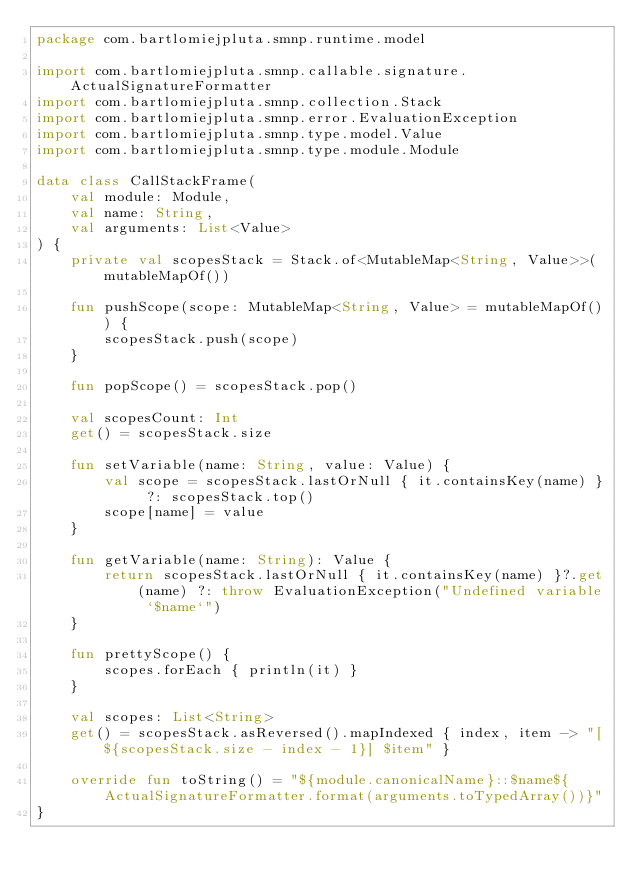<code> <loc_0><loc_0><loc_500><loc_500><_Kotlin_>package com.bartlomiejpluta.smnp.runtime.model

import com.bartlomiejpluta.smnp.callable.signature.ActualSignatureFormatter
import com.bartlomiejpluta.smnp.collection.Stack
import com.bartlomiejpluta.smnp.error.EvaluationException
import com.bartlomiejpluta.smnp.type.model.Value
import com.bartlomiejpluta.smnp.type.module.Module

data class CallStackFrame(
    val module: Module,
    val name: String,
    val arguments: List<Value>
) {
    private val scopesStack = Stack.of<MutableMap<String, Value>>(mutableMapOf())

    fun pushScope(scope: MutableMap<String, Value> = mutableMapOf()) {
        scopesStack.push(scope)
    }

    fun popScope() = scopesStack.pop()

    val scopesCount: Int
    get() = scopesStack.size

    fun setVariable(name: String, value: Value) {
        val scope = scopesStack.lastOrNull { it.containsKey(name) } ?: scopesStack.top()
        scope[name] = value
    }

    fun getVariable(name: String): Value {
        return scopesStack.lastOrNull { it.containsKey(name) }?.get(name) ?: throw EvaluationException("Undefined variable `$name`")
    }

    fun prettyScope() {
        scopes.forEach { println(it) }
    }

    val scopes: List<String>
    get() = scopesStack.asReversed().mapIndexed { index, item -> "[${scopesStack.size - index - 1}] $item" }

    override fun toString() = "${module.canonicalName}::$name${ActualSignatureFormatter.format(arguments.toTypedArray())}"
}</code> 